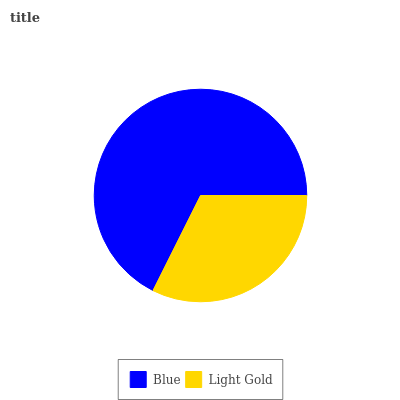Is Light Gold the minimum?
Answer yes or no. Yes. Is Blue the maximum?
Answer yes or no. Yes. Is Light Gold the maximum?
Answer yes or no. No. Is Blue greater than Light Gold?
Answer yes or no. Yes. Is Light Gold less than Blue?
Answer yes or no. Yes. Is Light Gold greater than Blue?
Answer yes or no. No. Is Blue less than Light Gold?
Answer yes or no. No. Is Blue the high median?
Answer yes or no. Yes. Is Light Gold the low median?
Answer yes or no. Yes. Is Light Gold the high median?
Answer yes or no. No. Is Blue the low median?
Answer yes or no. No. 